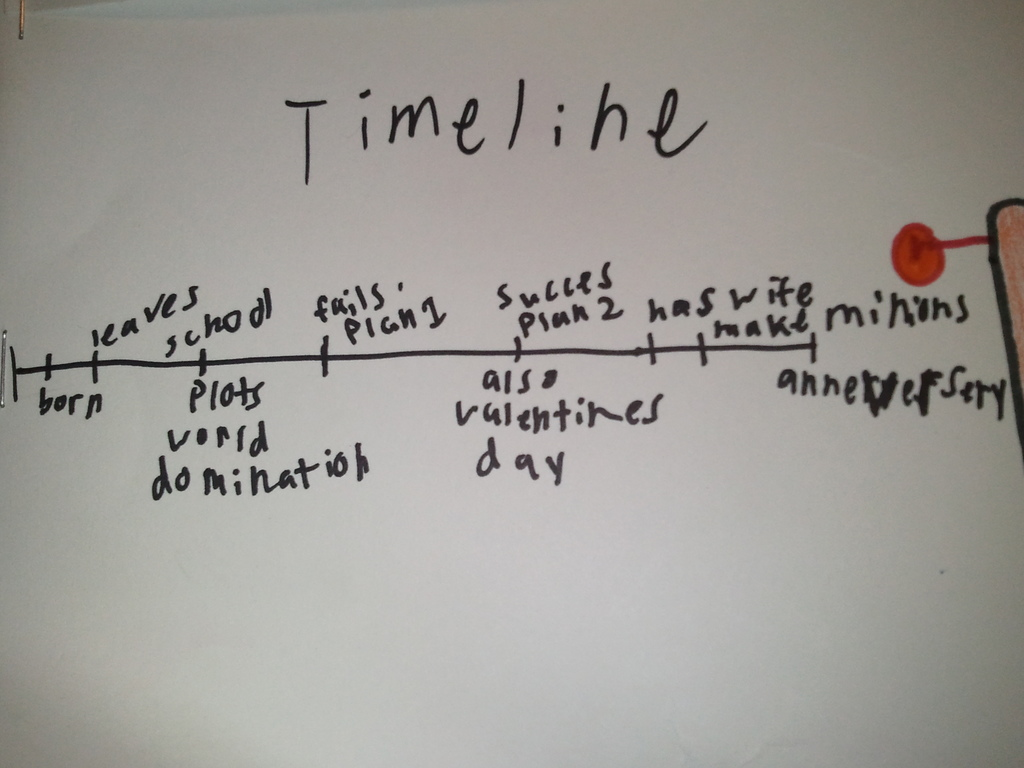What is this photo about? This photo features a creative hand-drawn timeline titled 'Timeline,' which humorously traces key life milestones. Starting with 'born,' the timeline includes fanciful events such as 'leaves school,' 'plots world domination,' 'fails plan,' and 'success plan 2,' which humorously implies a second attempt at world domination. Noteworthy, plan 2's success aligns with 'also valentines day,' adding a whimsical touch. Additionally, there are events like 'has wife,' 'thank minions,' and 'anniversary' that suggest personal achievements and gratitude. The timeline is pinned with a red pushpin on the right side, implying a work in progress or a moment to be revisited in the future. The depicted events, while playful, chart a fictional character's whimsical journey through life with milestones that blend fantasy and personal moments. 